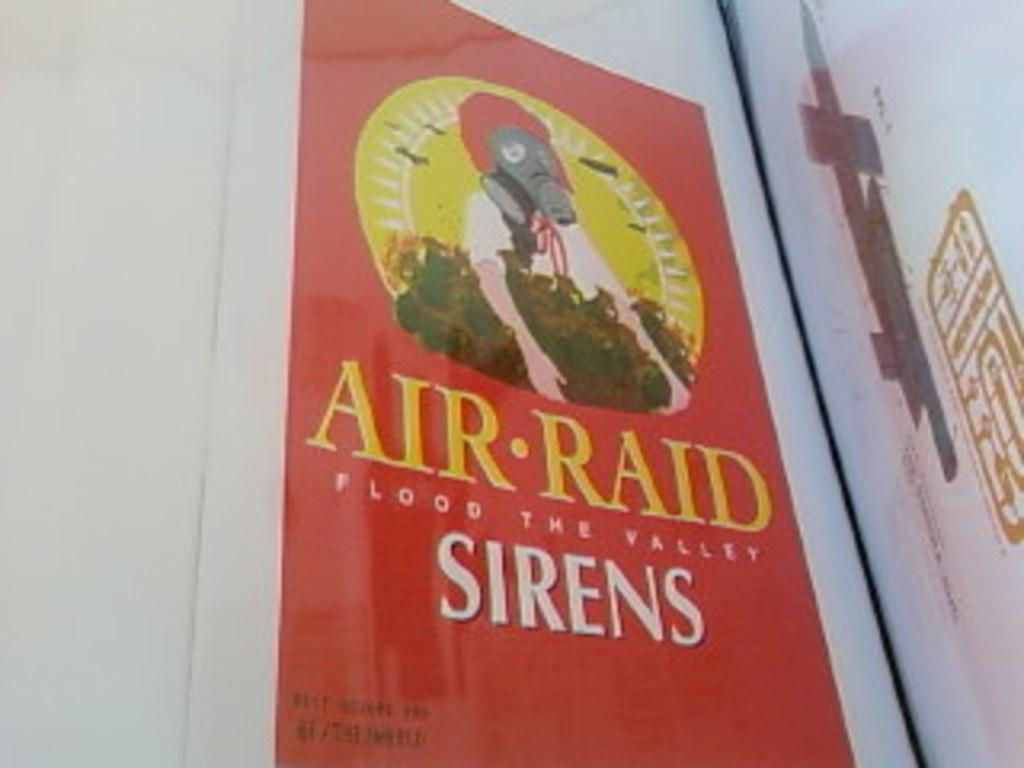<image>
Summarize the visual content of the image. An ad for Air Raid Sirens looks like a sunmaid raisins container 